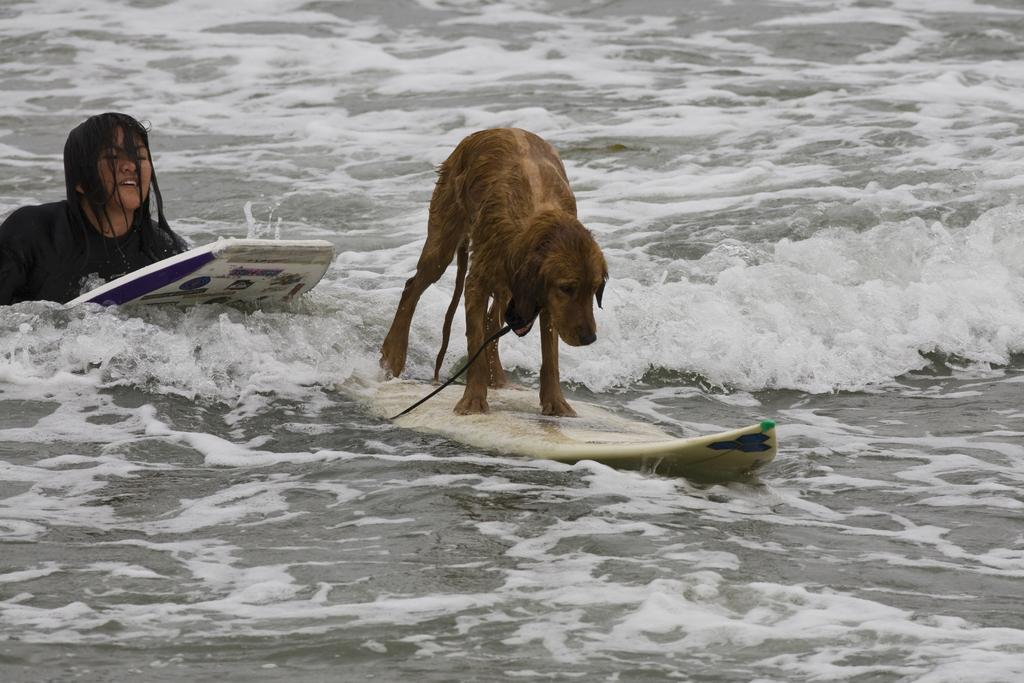What animals are present in the image? There is a dog on a surfboard in the image. What other subjects are on a surfboard in the image? There is a woman on a surfboard in the image. Where are the dog and woman located in the image? The dog and woman are in the center of the image. How is the woman positioned in relation to the dog? The woman is on the left side of the image. What can be seen in the background of the image? Water is visible in the background of the image. What time is displayed on the clock in the image? There is no clock present in the image. Who created the dog and woman in the image? The image is a photograph, not a creation, so there is no creator of the dog and woman in the image. 